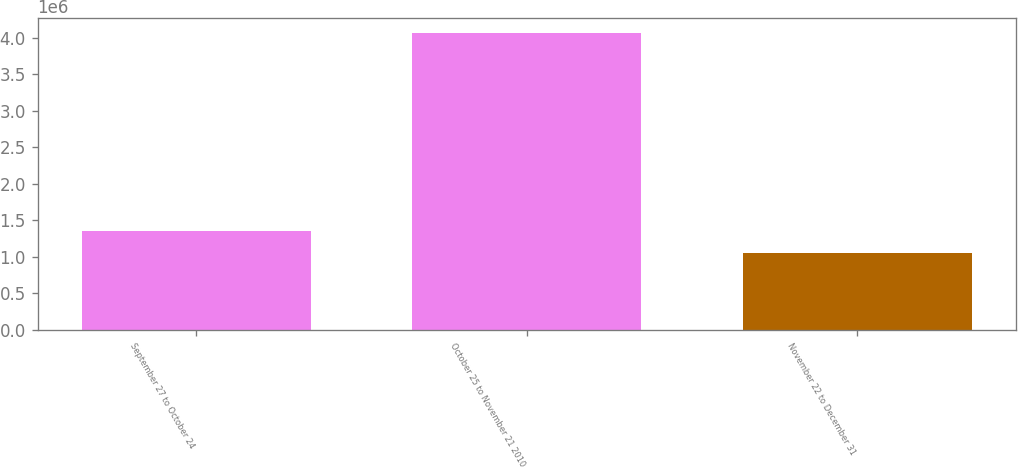Convert chart to OTSL. <chart><loc_0><loc_0><loc_500><loc_500><bar_chart><fcel>September 27 to October 24<fcel>October 25 to November 21 2010<fcel>November 22 to December 31<nl><fcel>1.35704e+06<fcel>4.07026e+06<fcel>1.05558e+06<nl></chart> 